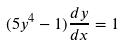<formula> <loc_0><loc_0><loc_500><loc_500>( 5 y ^ { 4 } - 1 ) \frac { d y } { d x } = 1</formula> 